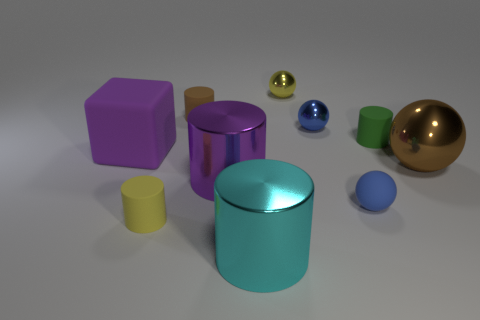Subtract 1 cylinders. How many cylinders are left? 4 Subtract all purple cylinders. How many cylinders are left? 4 Subtract all cyan metallic cylinders. How many cylinders are left? 4 Subtract all blue cylinders. Subtract all yellow blocks. How many cylinders are left? 5 Subtract all balls. How many objects are left? 6 Subtract all large spheres. Subtract all big shiny things. How many objects are left? 6 Add 2 small metallic balls. How many small metallic balls are left? 4 Add 6 big metal cylinders. How many big metal cylinders exist? 8 Subtract 1 green cylinders. How many objects are left? 9 